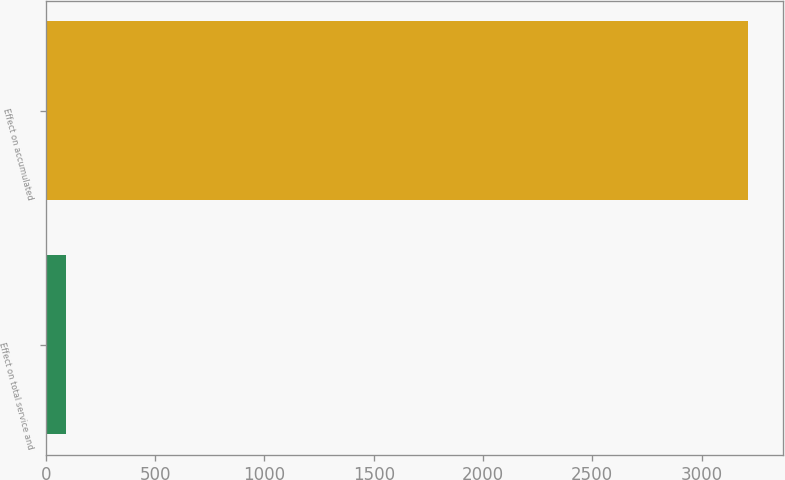Convert chart to OTSL. <chart><loc_0><loc_0><loc_500><loc_500><bar_chart><fcel>Effect on total service and<fcel>Effect on accumulated<nl><fcel>94<fcel>3213<nl></chart> 